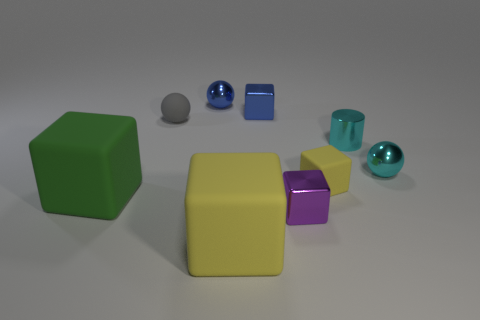Subtract all purple metal blocks. How many blocks are left? 4 Subtract 1 blocks. How many blocks are left? 4 Subtract all blue cubes. How many cubes are left? 4 Subtract all red blocks. Subtract all green cylinders. How many blocks are left? 5 Subtract all spheres. How many objects are left? 6 Add 4 blue metal balls. How many blue metal balls exist? 5 Subtract 0 yellow spheres. How many objects are left? 9 Subtract all tiny things. Subtract all small blue metal cylinders. How many objects are left? 2 Add 7 blue metallic spheres. How many blue metallic spheres are left? 8 